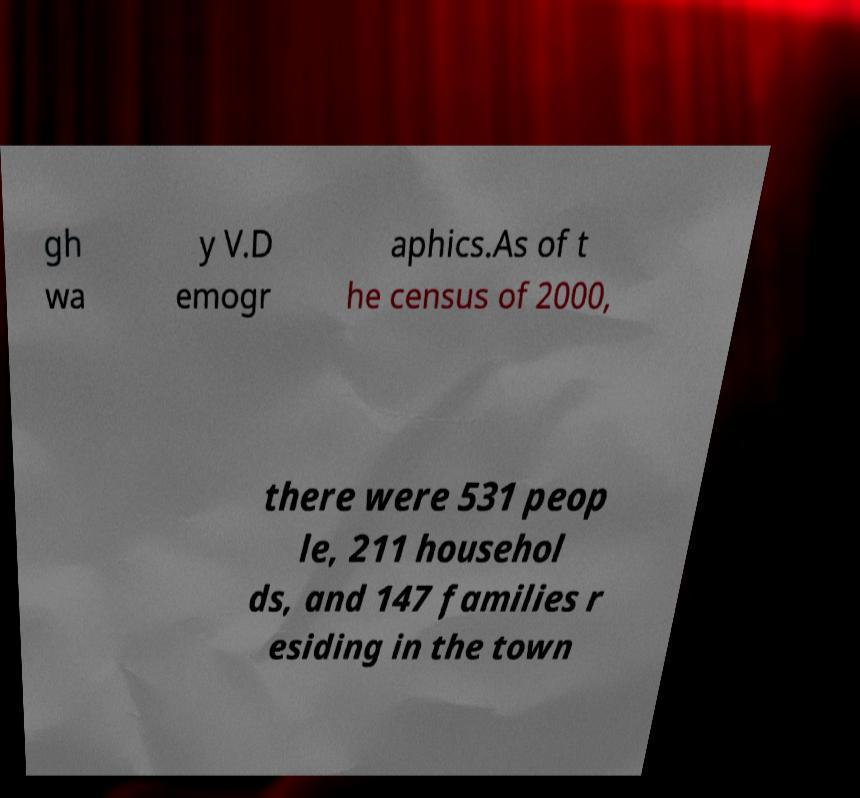Could you assist in decoding the text presented in this image and type it out clearly? gh wa y V.D emogr aphics.As of t he census of 2000, there were 531 peop le, 211 househol ds, and 147 families r esiding in the town 